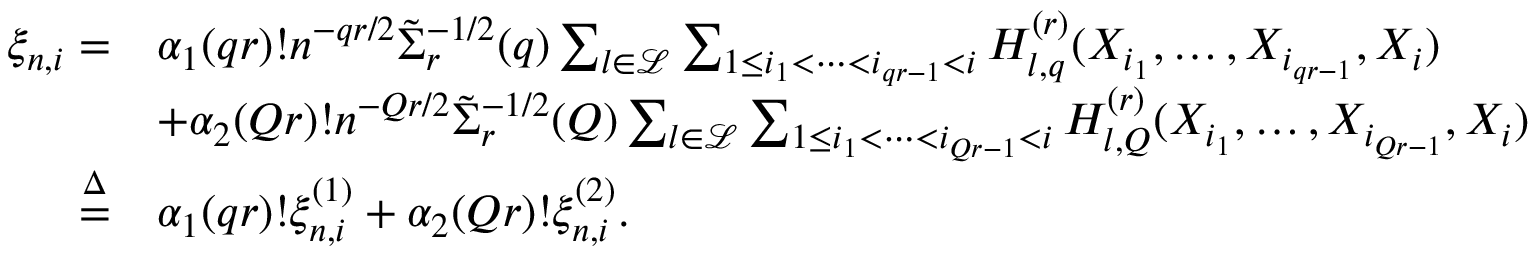<formula> <loc_0><loc_0><loc_500><loc_500>\begin{array} { r l } { \xi _ { n , i } = } & { \alpha _ { 1 } ( q r ) ! n ^ { - q r / 2 } \tilde { \Sigma } _ { r } ^ { - 1 / 2 } ( q ) \sum _ { l \in \mathcal { L } } \sum _ { 1 \leq i _ { 1 } < \cdots < i _ { q r - 1 } < i } H _ { l , q } ^ { ( r ) } ( X _ { i _ { 1 } } , \dots , X _ { i _ { q r - 1 } } , X _ { i } ) } \\ & { + \alpha _ { 2 } ( Q r ) ! n ^ { - Q r / 2 } \tilde { \Sigma } _ { r } ^ { - 1 / 2 } ( Q ) \sum _ { l \in \mathcal { L } } \sum _ { 1 \leq i _ { 1 } < \cdots < i _ { Q r - 1 } < i } H _ { l , Q } ^ { ( r ) } ( X _ { i _ { 1 } } , \dots , X _ { i _ { Q r - 1 } } , X _ { i } ) } \\ { \overset { \Delta } { = } } & { \alpha _ { 1 } ( q r ) ! \xi _ { n , i } ^ { ( 1 ) } + \alpha _ { 2 } ( Q r ) ! \xi _ { n , i } ^ { ( 2 ) } . } \end{array}</formula> 